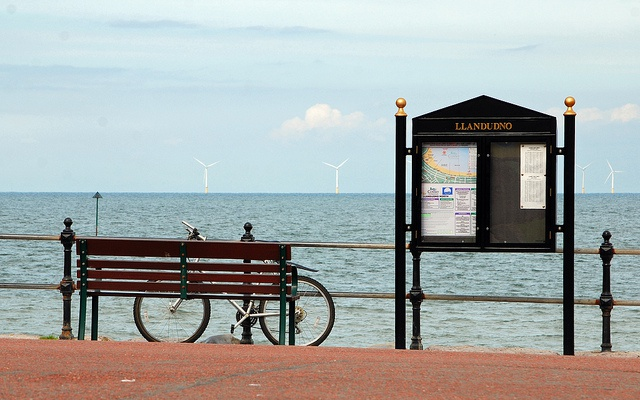Describe the objects in this image and their specific colors. I can see bench in lightblue, black, maroon, darkgray, and gray tones and bicycle in lightblue, darkgray, black, and lightgray tones in this image. 